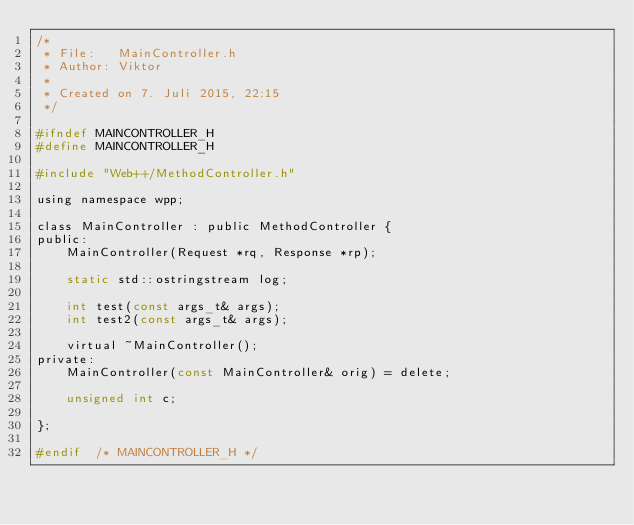<code> <loc_0><loc_0><loc_500><loc_500><_C_>/* 
 * File:   MainController.h
 * Author: Viktor
 *
 * Created on 7. Juli 2015, 22:15
 */

#ifndef MAINCONTROLLER_H
#define	MAINCONTROLLER_H

#include "Web++/MethodController.h"

using namespace wpp;

class MainController : public MethodController {
public:
    MainController(Request *rq, Response *rp);
    
    static std::ostringstream log;
    
    int test(const args_t& args);
    int test2(const args_t& args);
    
    virtual ~MainController();
private:
    MainController(const MainController& orig) = delete;
    
    unsigned int c;

};

#endif	/* MAINCONTROLLER_H */

</code> 